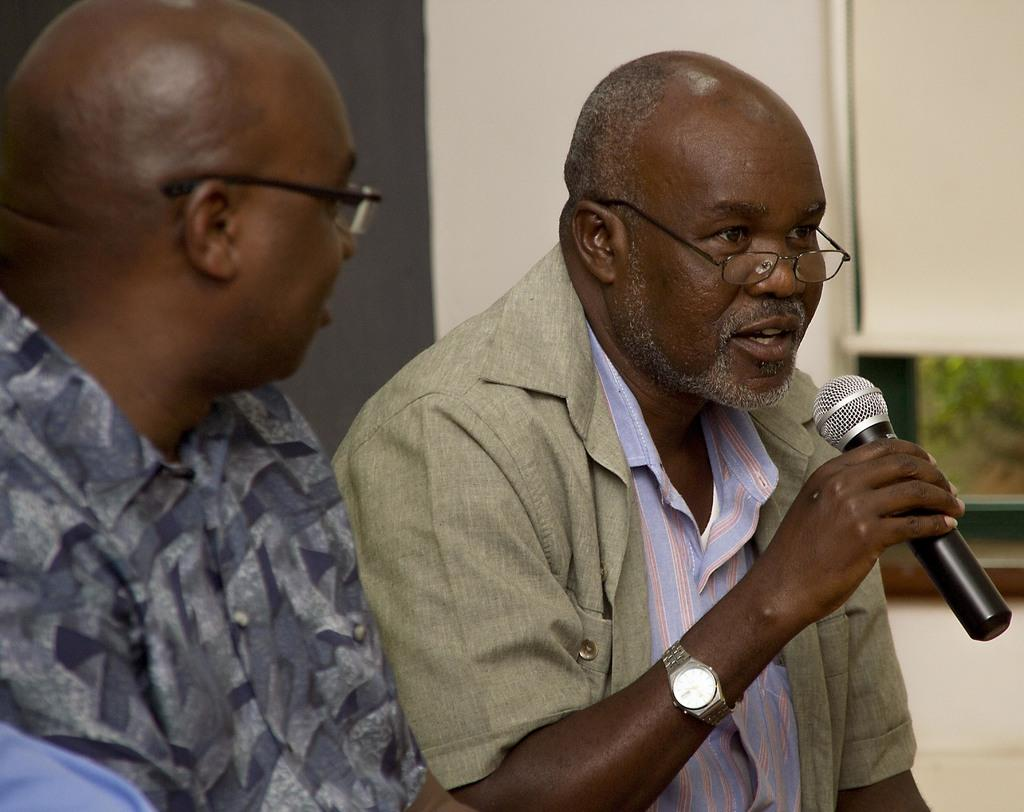How many people are in the image? There are two persons in the image. What are the two persons doing? The two persons are sitting. What can be seen in the background of the image? The image has a wall in the background. What is the person on the right side holding? The right side person is holding a black color Mix. What type of flesh can be seen on the person's arm in the image? There is no flesh visible on the person's arm in the image. Can you tell me how many experts are present in the image? There is no mention of experts in the image, as it features two persons sitting. 